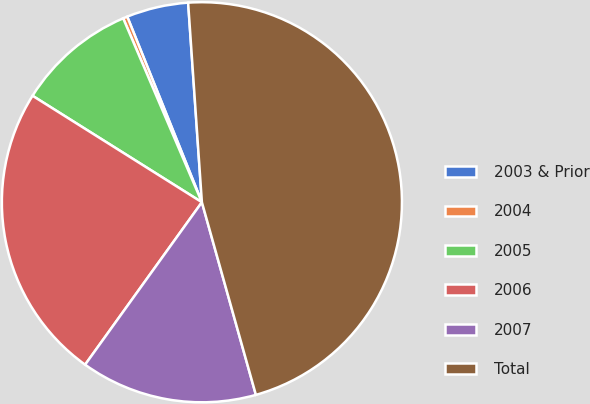Convert chart to OTSL. <chart><loc_0><loc_0><loc_500><loc_500><pie_chart><fcel>2003 & Prior<fcel>2004<fcel>2005<fcel>2006<fcel>2007<fcel>Total<nl><fcel>4.99%<fcel>0.35%<fcel>9.63%<fcel>24.01%<fcel>14.27%<fcel>46.74%<nl></chart> 